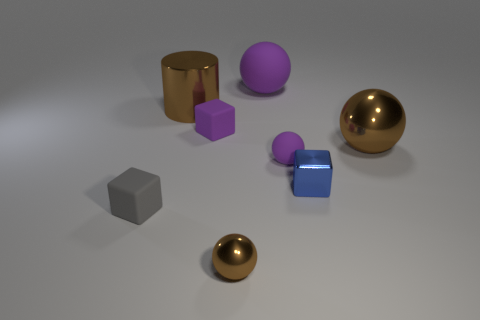Subtract 1 balls. How many balls are left? 3 Add 1 small blue shiny things. How many objects exist? 9 Subtract all blocks. How many objects are left? 5 Add 1 large rubber balls. How many large rubber balls are left? 2 Add 4 small purple spheres. How many small purple spheres exist? 5 Subtract 0 red cubes. How many objects are left? 8 Subtract all big green matte objects. Subtract all big matte spheres. How many objects are left? 7 